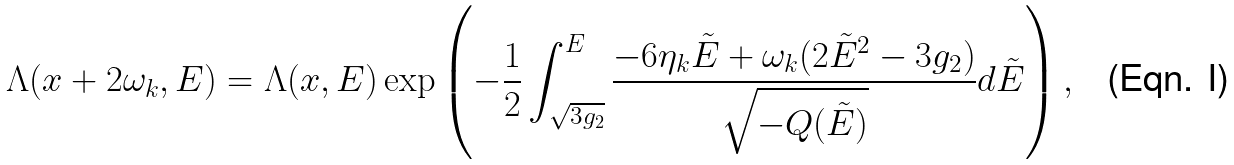Convert formula to latex. <formula><loc_0><loc_0><loc_500><loc_500>& \Lambda ( x + 2 \omega _ { k } , E ) = \Lambda ( x , E ) \exp \left ( - \frac { 1 } { 2 } \int _ { \sqrt { 3 g _ { 2 } } } ^ { E } \frac { - 6 \eta _ { k } \tilde { E } + \omega _ { k } ( 2 \tilde { E } ^ { 2 } - 3 g _ { 2 } ) } { \sqrt { - Q ( \tilde { E } ) } } d \tilde { E } \right ) ,</formula> 